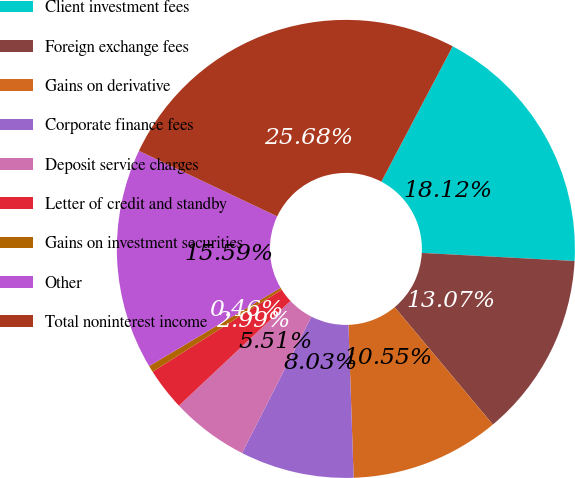Convert chart. <chart><loc_0><loc_0><loc_500><loc_500><pie_chart><fcel>Client investment fees<fcel>Foreign exchange fees<fcel>Gains on derivative<fcel>Corporate finance fees<fcel>Deposit service charges<fcel>Letter of credit and standby<fcel>Gains on investment securities<fcel>Other<fcel>Total noninterest income<nl><fcel>18.12%<fcel>13.07%<fcel>10.55%<fcel>8.03%<fcel>5.51%<fcel>2.99%<fcel>0.46%<fcel>15.59%<fcel>25.68%<nl></chart> 